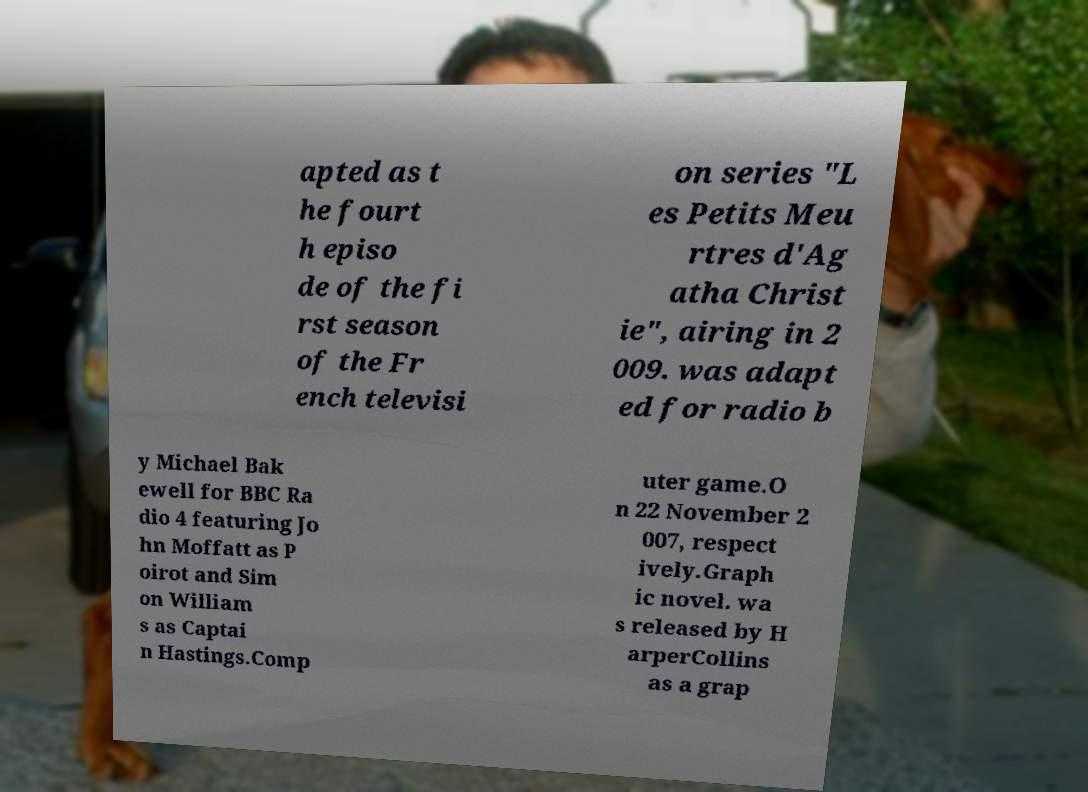Could you assist in decoding the text presented in this image and type it out clearly? apted as t he fourt h episo de of the fi rst season of the Fr ench televisi on series "L es Petits Meu rtres d'Ag atha Christ ie", airing in 2 009. was adapt ed for radio b y Michael Bak ewell for BBC Ra dio 4 featuring Jo hn Moffatt as P oirot and Sim on William s as Captai n Hastings.Comp uter game.O n 22 November 2 007, respect ively.Graph ic novel. wa s released by H arperCollins as a grap 